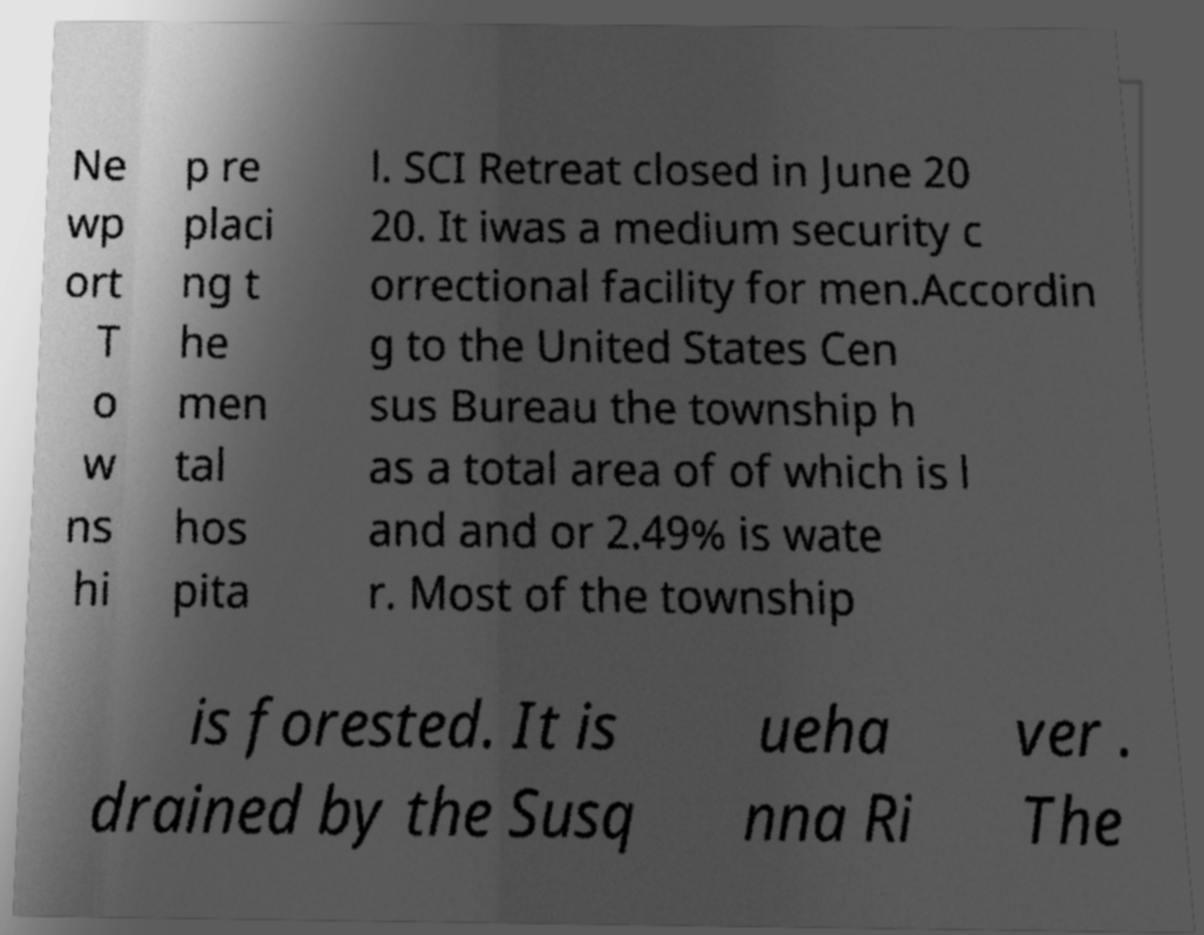What messages or text are displayed in this image? I need them in a readable, typed format. Ne wp ort T o w ns hi p re placi ng t he men tal hos pita l. SCI Retreat closed in June 20 20. It iwas a medium security c orrectional facility for men.Accordin g to the United States Cen sus Bureau the township h as a total area of of which is l and and or 2.49% is wate r. Most of the township is forested. It is drained by the Susq ueha nna Ri ver . The 